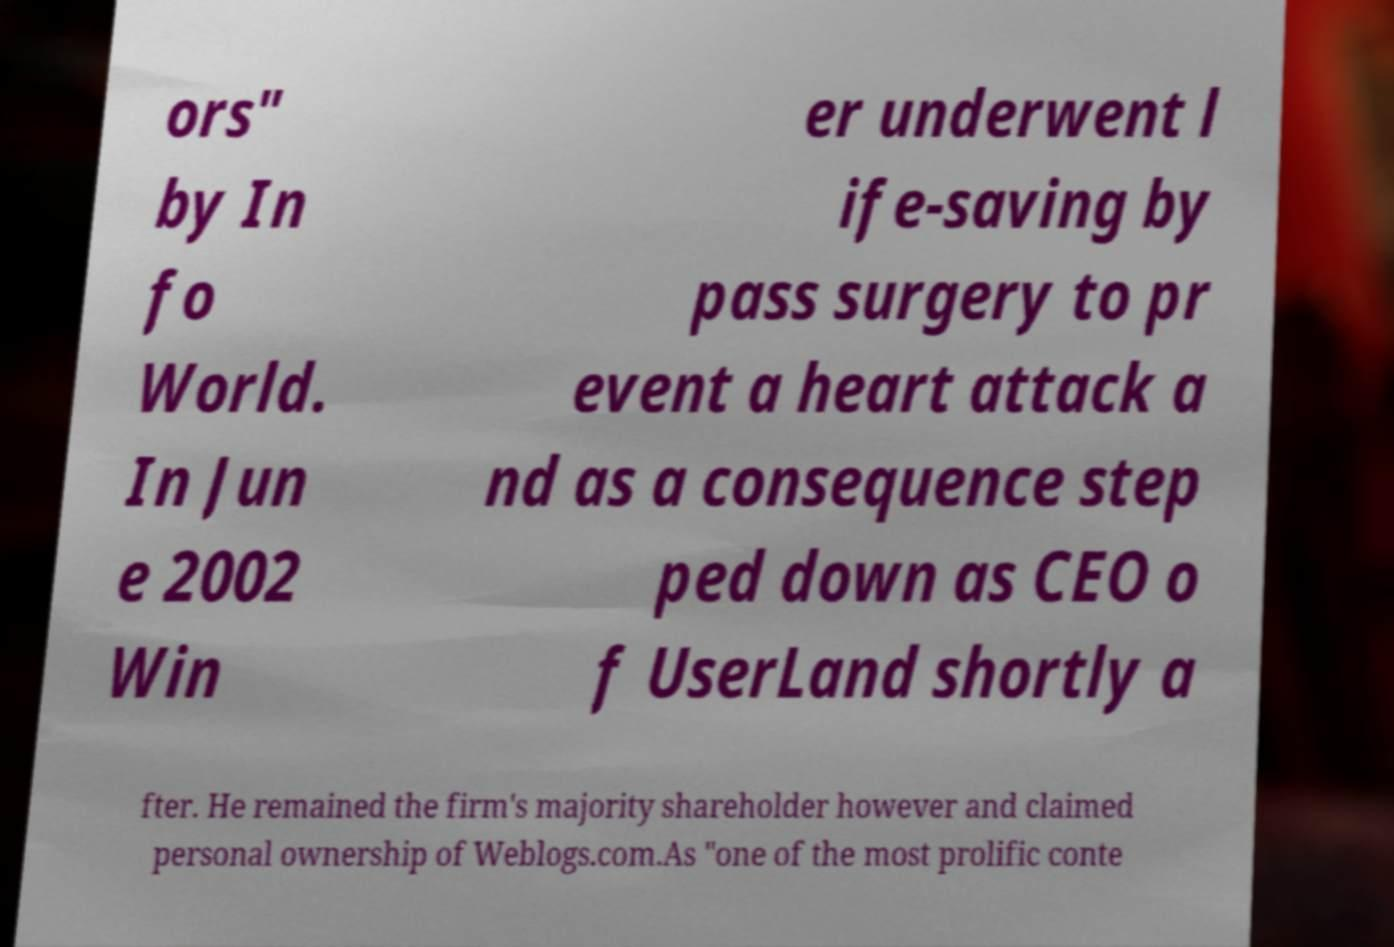For documentation purposes, I need the text within this image transcribed. Could you provide that? ors" by In fo World. In Jun e 2002 Win er underwent l ife-saving by pass surgery to pr event a heart attack a nd as a consequence step ped down as CEO o f UserLand shortly a fter. He remained the firm's majority shareholder however and claimed personal ownership of Weblogs.com.As "one of the most prolific conte 